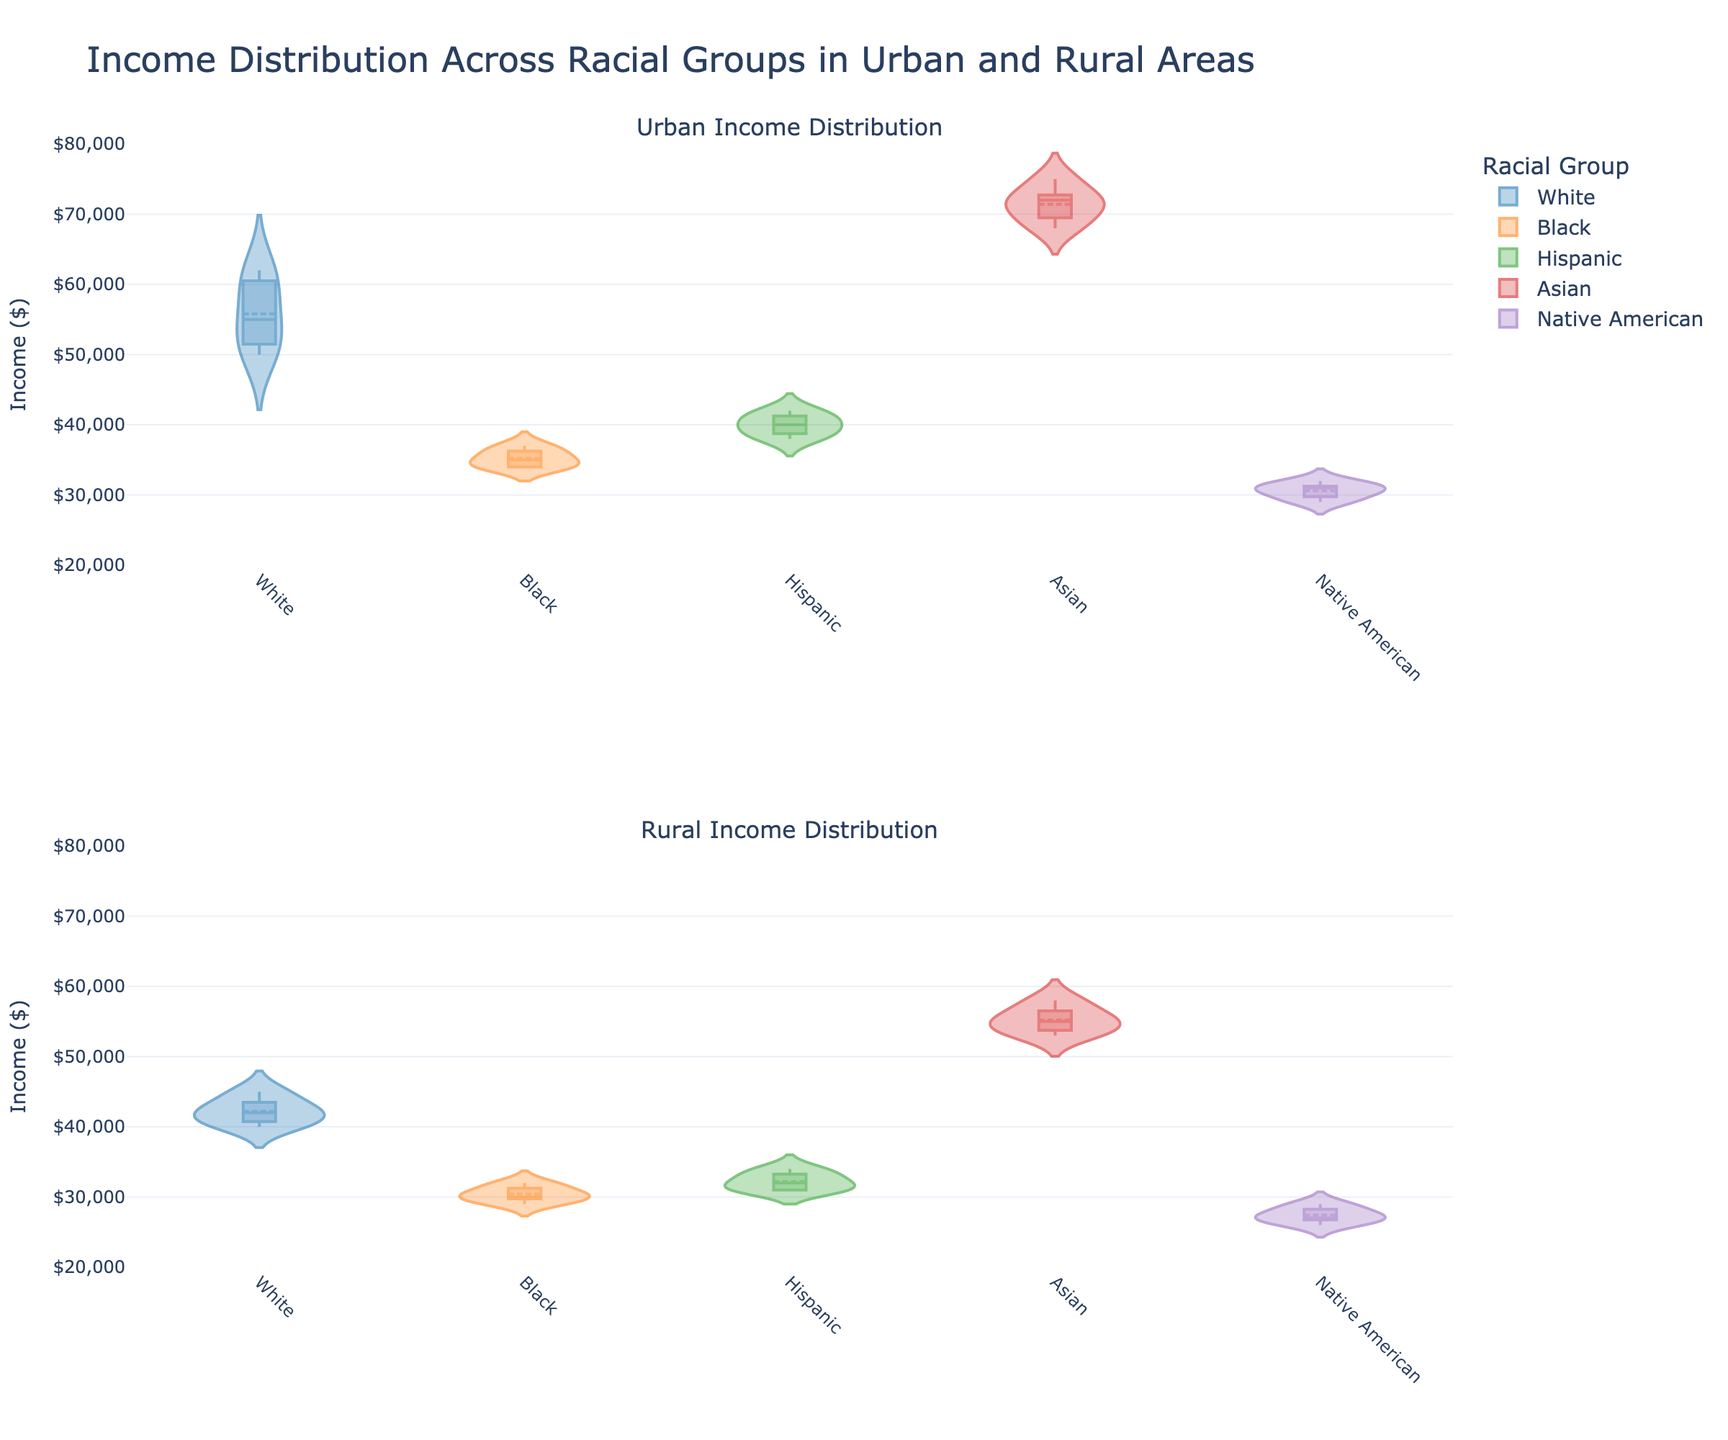What is the title of the subplot figure? The title is typically found at the top of the figure in a larger font. For this figure, it should be a brief descriptor summarizing the main content.
Answer: Income Distribution Across Racial Groups in Urban and Rural Areas What are the distinct racial groups represented in the figure? To answer this, look at the legends or the axis labels where each racial group is delineated. The figure uses different colors to represent: White, Black, Hispanic, Asian, and Native American.
Answer: White, Black, Hispanic, Asian, Native American How does the median income of the White racial group in Urban areas compare to that in Rural areas? Find the midpoint line in the violin plots for the White racial group in both subplots. By comparing their positions on the vertical axis marked with income values, we can see the difference.
Answer: Higher in Urban Which racial group has the highest median income in Urban areas? Look at the Urban Income Distribution subplot. Assess the position of the median lines (in the middle of each violin) relative to the income axis. The highest position indicates the highest median income.
Answer: Asian Which racial group shows the lowest range of incomes in Rural areas? Examine the width of the violin plots for each racial group in the Rural Income Distribution subplot. The group with the narrowest plot has the lowest range of incomes.
Answer: Native American Is there a difference between the income distributions of the Black racial group in Urban and Rural areas? Compare the overall shapes and spread of the violin plots for the Black racial group in both subplots. Look for wider spreads, shifts in medians, and overlap.
Answer: Yes Which racial group in Rural areas has a similar income distribution to Hispanics in the same area? Look at the shape, spread, and central tendency (median line) of the Hispanics' income distribution in the Rural subplot. Compare these visual aspects to other racial groups in the same subplot.
Answer: Black What is the range of incomes for Asians in Urban areas? For the Asian racial group in the Urban subplot, observe the highest and lowest points of the violin plot to determine the span of incomes.
Answer: $68,000 to $75,000 Do Native Americans have a higher median income in Urban areas compared to Rural areas? Find the median lines in the violin plots for Native Americans in both Urban and Rural subplots. Compare the two positions on the vertical axis.
Answer: Yes Which racial group has the most variable income distribution in Urban areas? Assess the width and spread of each violin plot in the Urban subplot. The one with the widest spread indicates the greatest variability.
Answer: White 